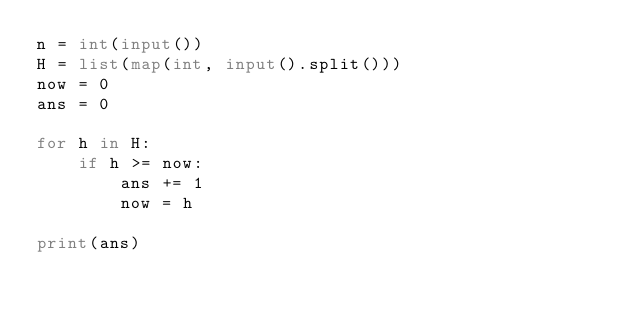<code> <loc_0><loc_0><loc_500><loc_500><_Python_>n = int(input())
H = list(map(int, input().split()))
now = 0
ans = 0

for h in H:
    if h >= now:
        ans += 1
        now = h

print(ans)</code> 